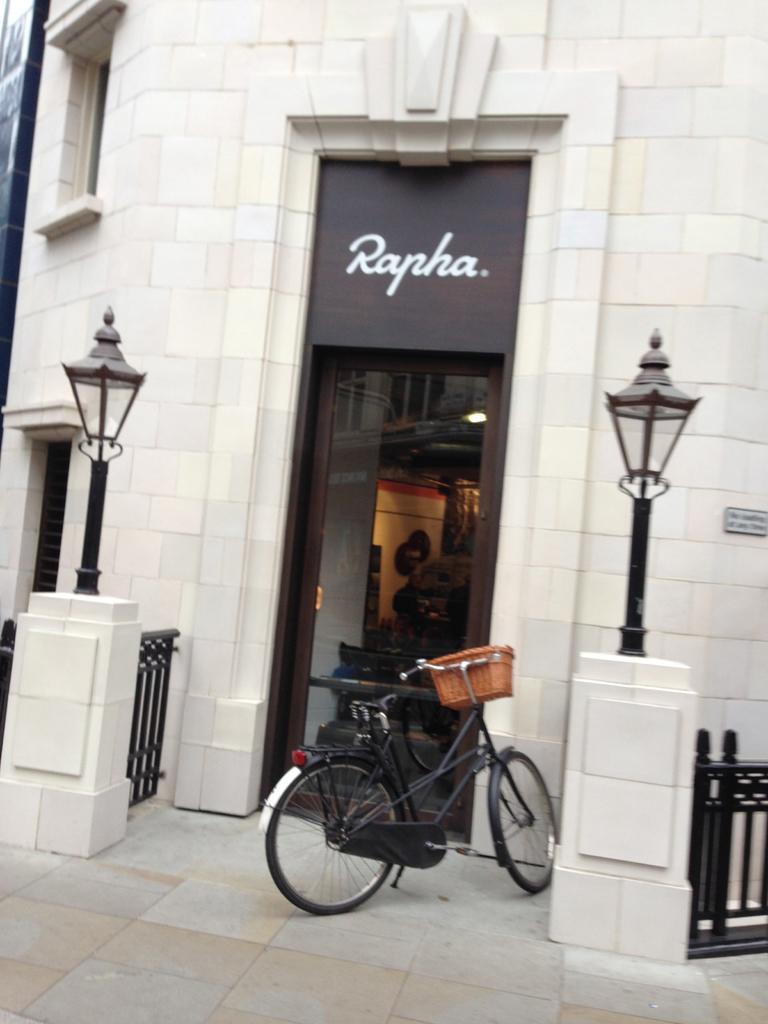In one or two sentences, can you explain what this image depicts? In this picture there is a bicycle which is parked near to the gate, fencing and the street lights. At the top we can see the building. In the center there is a door. In the top left corner there is a window. 